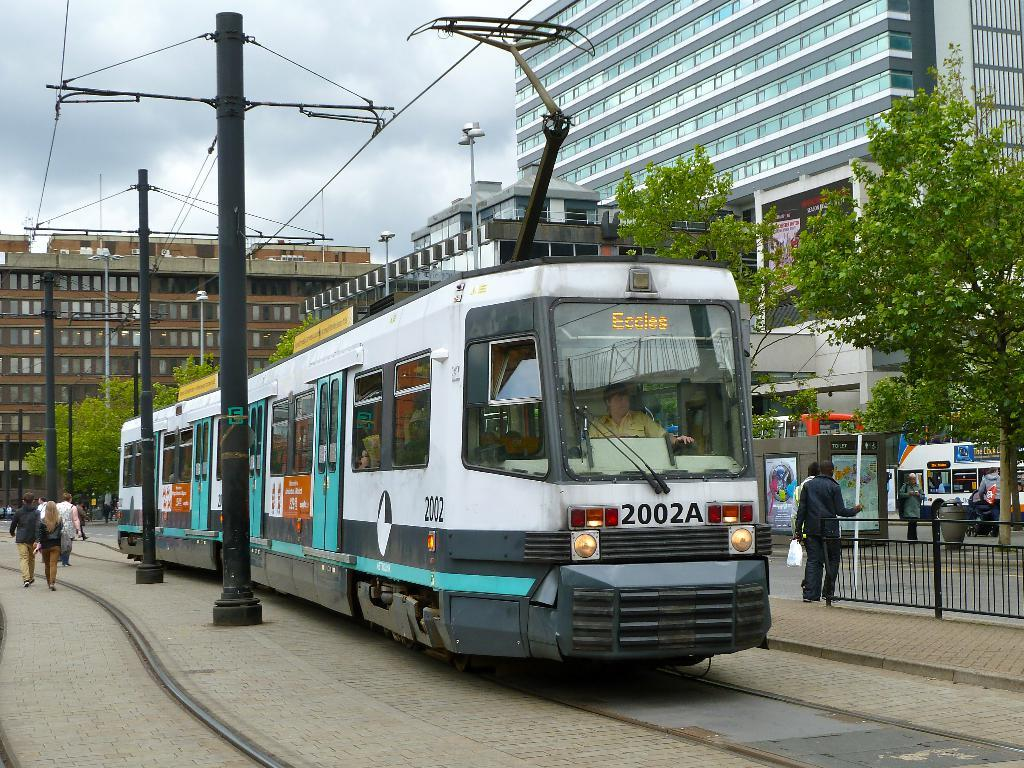<image>
Relay a brief, clear account of the picture shown. A streetcar with 2002A on the front heading for Eccles. 